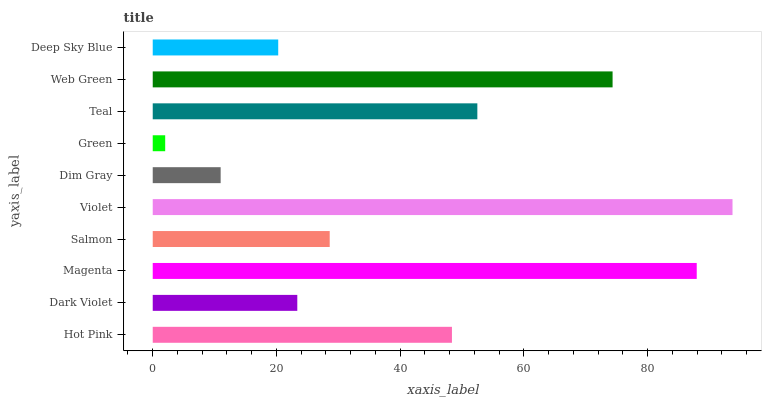Is Green the minimum?
Answer yes or no. Yes. Is Violet the maximum?
Answer yes or no. Yes. Is Dark Violet the minimum?
Answer yes or no. No. Is Dark Violet the maximum?
Answer yes or no. No. Is Hot Pink greater than Dark Violet?
Answer yes or no. Yes. Is Dark Violet less than Hot Pink?
Answer yes or no. Yes. Is Dark Violet greater than Hot Pink?
Answer yes or no. No. Is Hot Pink less than Dark Violet?
Answer yes or no. No. Is Hot Pink the high median?
Answer yes or no. Yes. Is Salmon the low median?
Answer yes or no. Yes. Is Magenta the high median?
Answer yes or no. No. Is Green the low median?
Answer yes or no. No. 